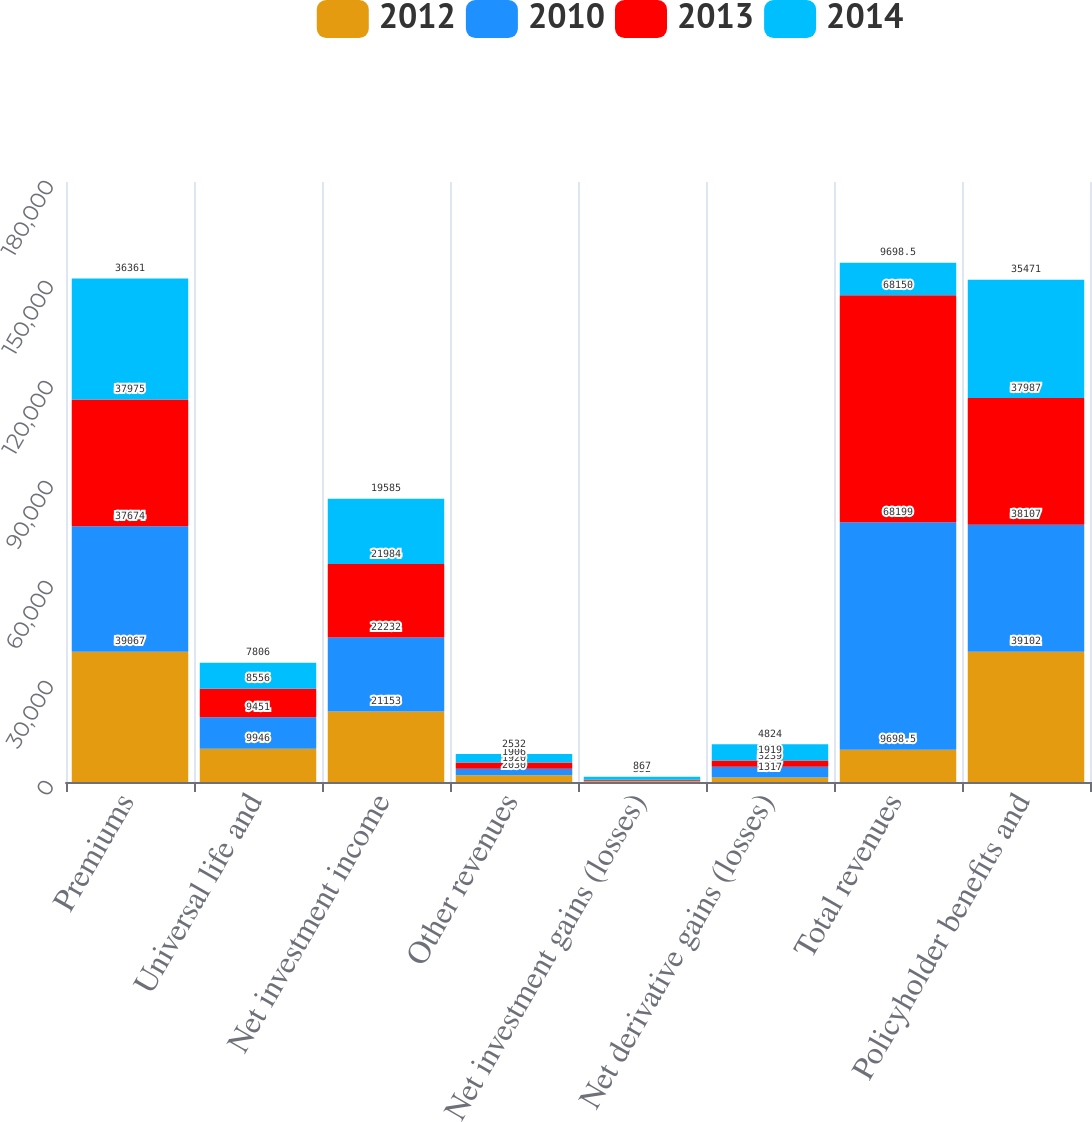Convert chart. <chart><loc_0><loc_0><loc_500><loc_500><stacked_bar_chart><ecel><fcel>Premiums<fcel>Universal life and<fcel>Net investment income<fcel>Other revenues<fcel>Net investment gains (losses)<fcel>Net derivative gains (losses)<fcel>Total revenues<fcel>Policyholder benefits and<nl><fcel>2012<fcel>39067<fcel>9946<fcel>21153<fcel>2030<fcel>197<fcel>1317<fcel>9698.5<fcel>39102<nl><fcel>2010<fcel>37674<fcel>9451<fcel>22232<fcel>1920<fcel>161<fcel>3239<fcel>68199<fcel>38107<nl><fcel>2013<fcel>37975<fcel>8556<fcel>21984<fcel>1906<fcel>352<fcel>1919<fcel>68150<fcel>37987<nl><fcel>2014<fcel>36361<fcel>7806<fcel>19585<fcel>2532<fcel>867<fcel>4824<fcel>9698.5<fcel>35471<nl></chart> 